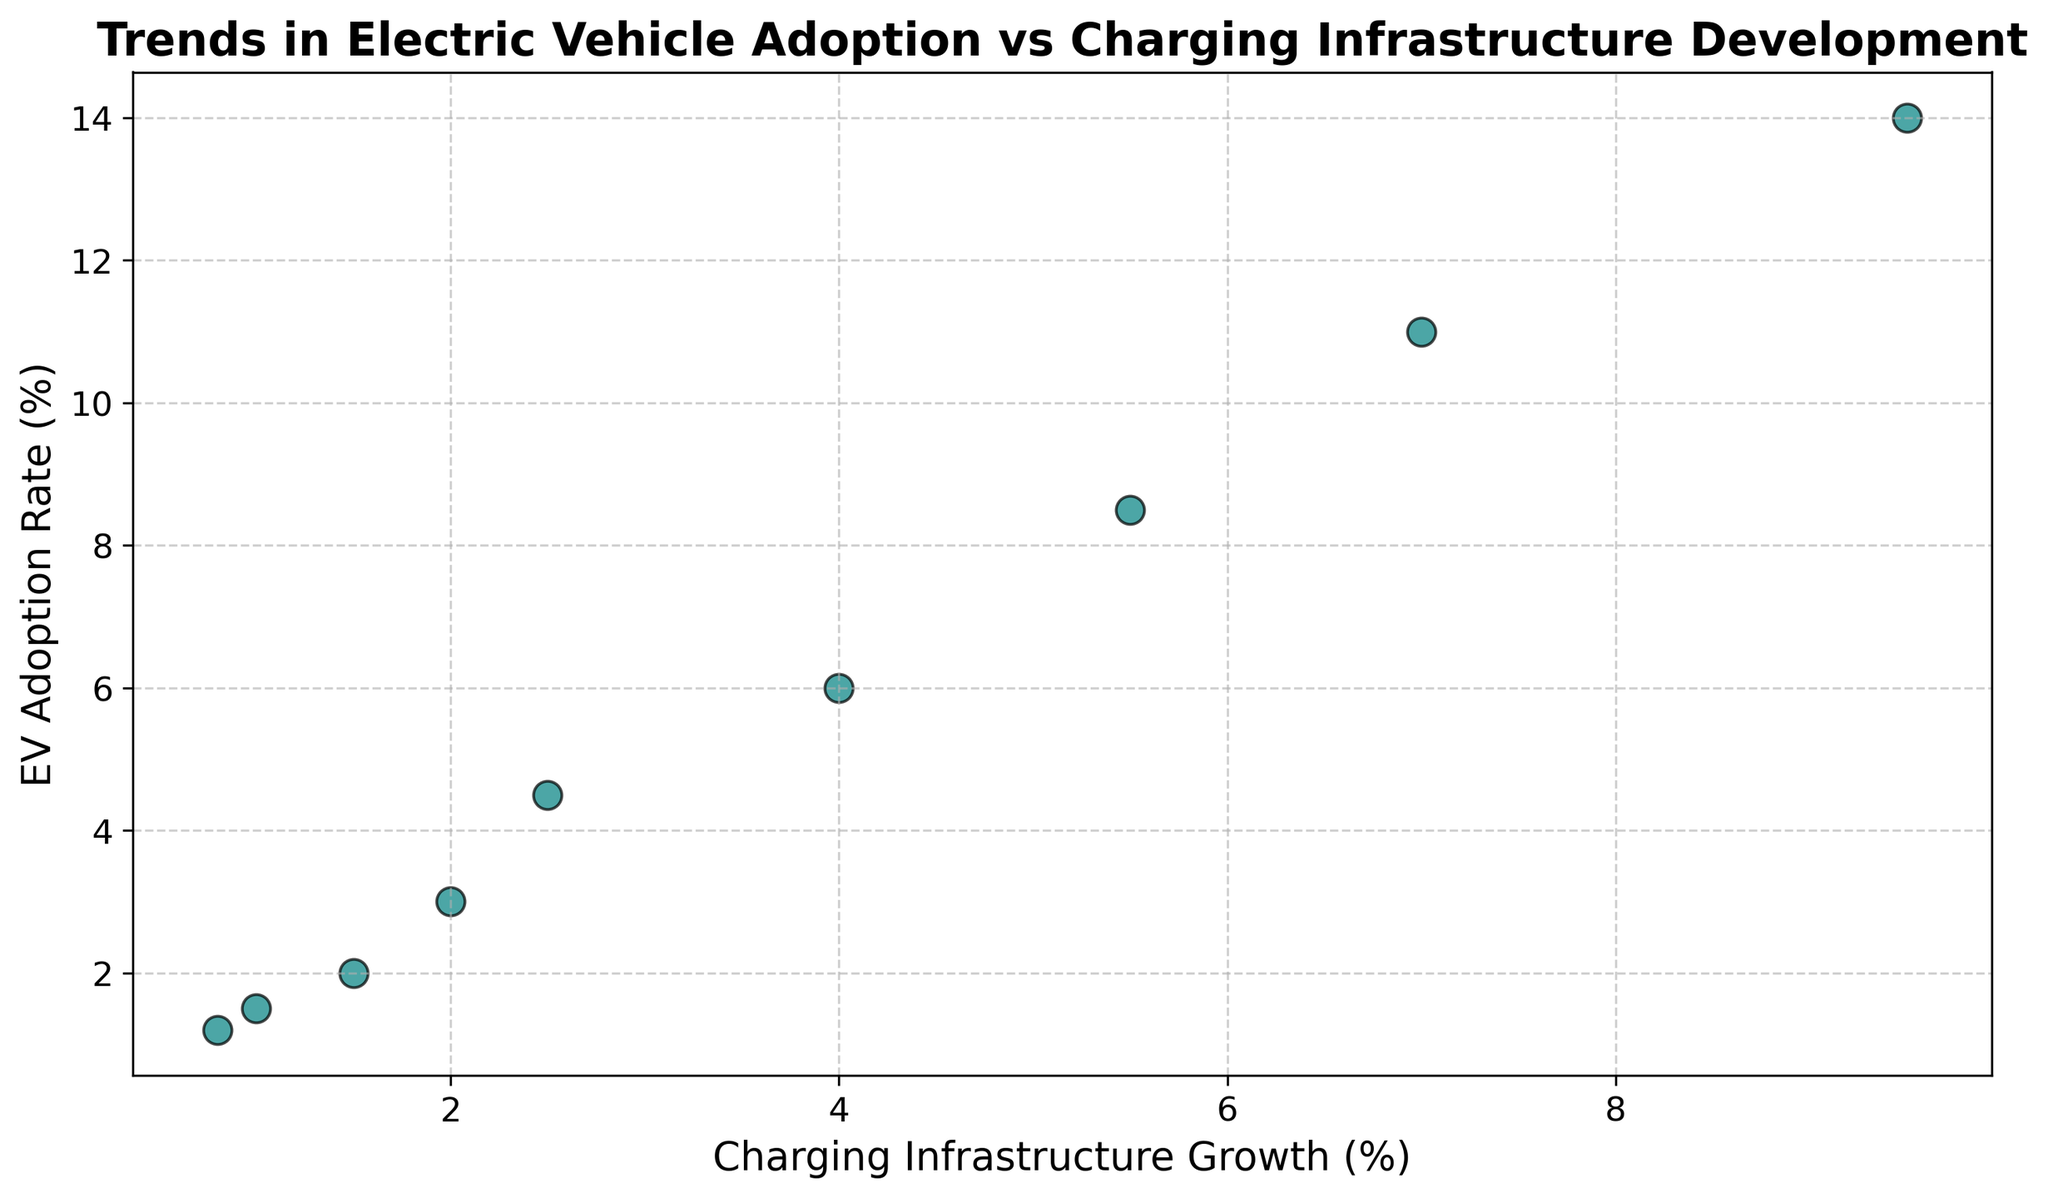What is the overall trend in electric vehicle adoption from 2015 to 2023? The scatter plot shows a consistent upward trend in EV adoption rates, starting from around 1.2% in 2015 and rising steadily to about 14.0% in 2023.
Answer: Upward trend How does the growth in charging infrastructure compare to the EV adoption rate over the years? Both the EV adoption rate and the charging infrastructure growth show a strong positive correlation. As the charging infrastructure grows from 0.8% to 9.5%, the EV adoption rate similarly increases from 1.2% to 14.0%.
Answer: Strong positive correlation In which year did the EV adoption rate show the highest increase compared to the previous year? To find the highest increase, calculate the yearly differences. The largest difference is from 2022 to 2023, where EV adoption increased from 11.0% to 14.0%, a difference of 3.0%.
Answer: 2023 Is the growth rate of charging infrastructure always less than the EV adoption rate? By scanning through the data points in the scatter plot, we see that in all years, the EV adoption rate exceeds the charging infrastructure growth rate.
Answer: Yes Which year had the smallest gap between EV adoption rate and charging infrastructure growth? Calculate the differences for each year: the smallest gap is in 2015 with a difference of 0.4% (1.2% - 0.8%).
Answer: 2015 How many years had the EV adoption rate more than double the charging infrastructure growth? Comparing the EV adoption rate to double the charging infrastructure growth for each year, we observe that in 2020, 2021, 2022, and 2023, the adoption rate exceeds twice the growth rate of the infrastructure.
Answer: 4 years What is the visual pattern created by the data points on the scatter plot? The data points create a visually increasing linear pattern, indicating that as charging infrastructure grows, the adoption rate of EVs also increases.
Answer: Increasing linear pattern How many years did the EV adoption rate increase by more than 2% compared to the previous year? By comparing the yearly differences, we see that in 2019-2020, 2020-2021, 2021-2022, and 2022-2023, the increase is more than 2%. Thus, 4 years.
Answer: 4 years In which year did the gap between EV adoption rate and charging infrastructure growth widen the most? Calculate the yearly differences between EV adoption rate and charging infrastructure growth. The largest gap appears in 2023 with a difference of 4.5% (14.0% - 9.5%).
Answer: 2023 